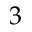<formula> <loc_0><loc_0><loc_500><loc_500>3</formula> 